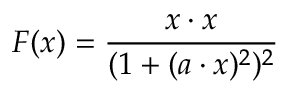<formula> <loc_0><loc_0><loc_500><loc_500>F ( x ) = { \frac { x \cdot x } { ( 1 + ( a \cdot x ) ^ { 2 } ) ^ { 2 } } }</formula> 